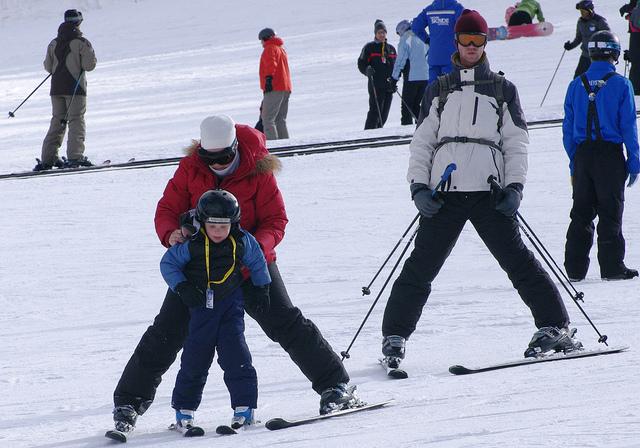Does the child look scared?
Keep it brief. No. Why is the person touching the child?
Keep it brief. Helping them ski. What color are the childs shoes?
Concise answer only. Blue. 